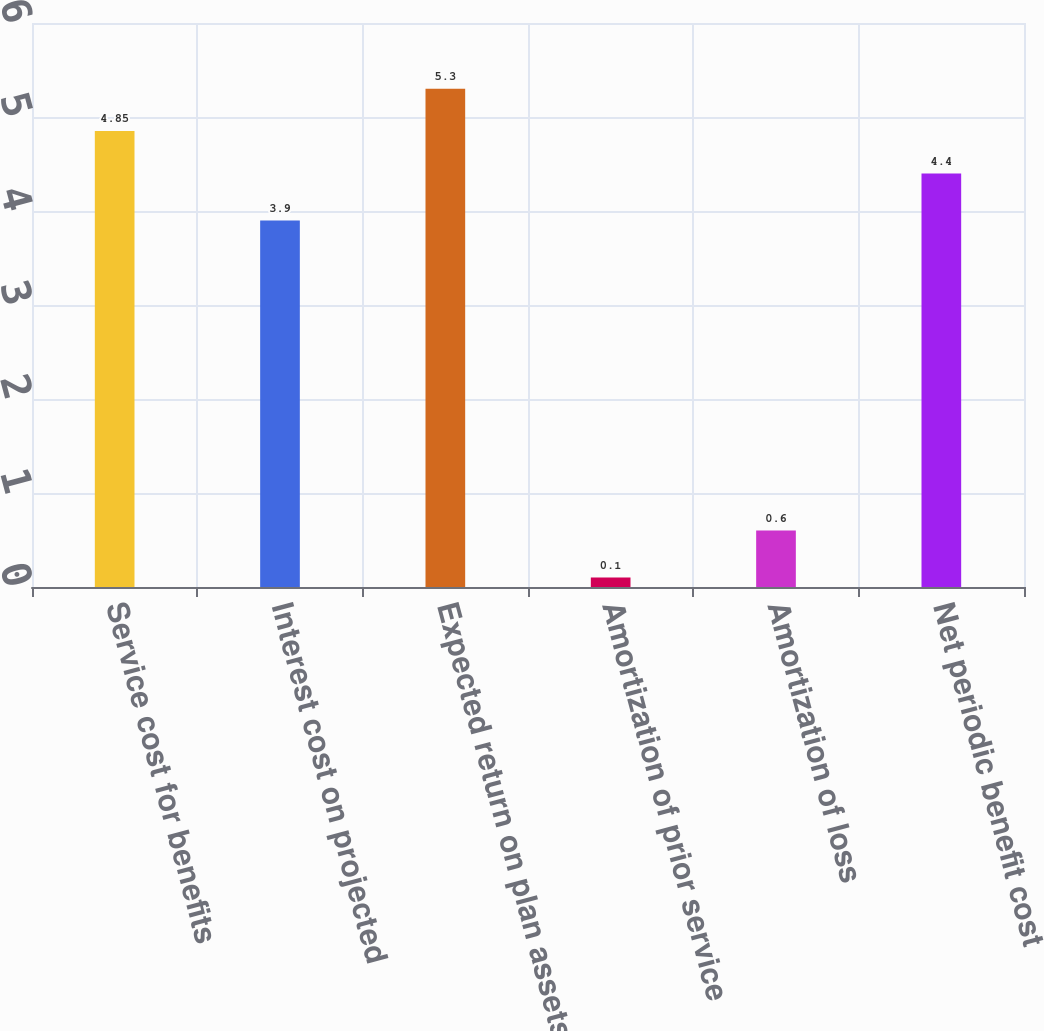Convert chart to OTSL. <chart><loc_0><loc_0><loc_500><loc_500><bar_chart><fcel>Service cost for benefits<fcel>Interest cost on projected<fcel>Expected return on plan assets<fcel>Amortization of prior service<fcel>Amortization of loss<fcel>Net periodic benefit cost<nl><fcel>4.85<fcel>3.9<fcel>5.3<fcel>0.1<fcel>0.6<fcel>4.4<nl></chart> 